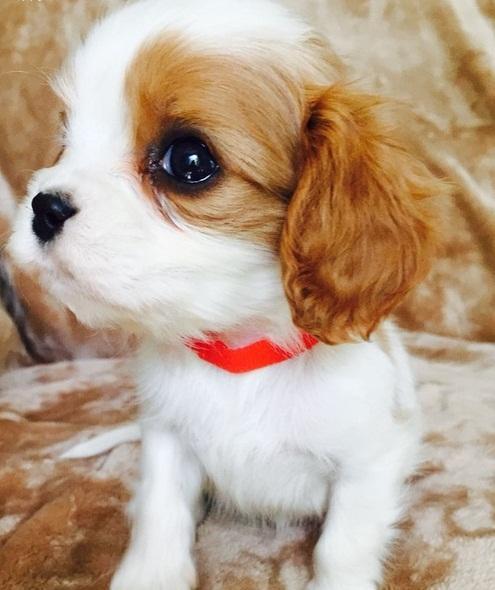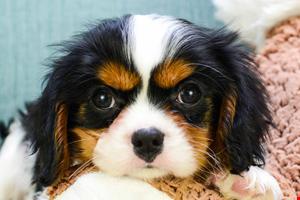The first image is the image on the left, the second image is the image on the right. Examine the images to the left and right. Is the description "One of the images shows an inanimate object with the dog." accurate? Answer yes or no. No. 